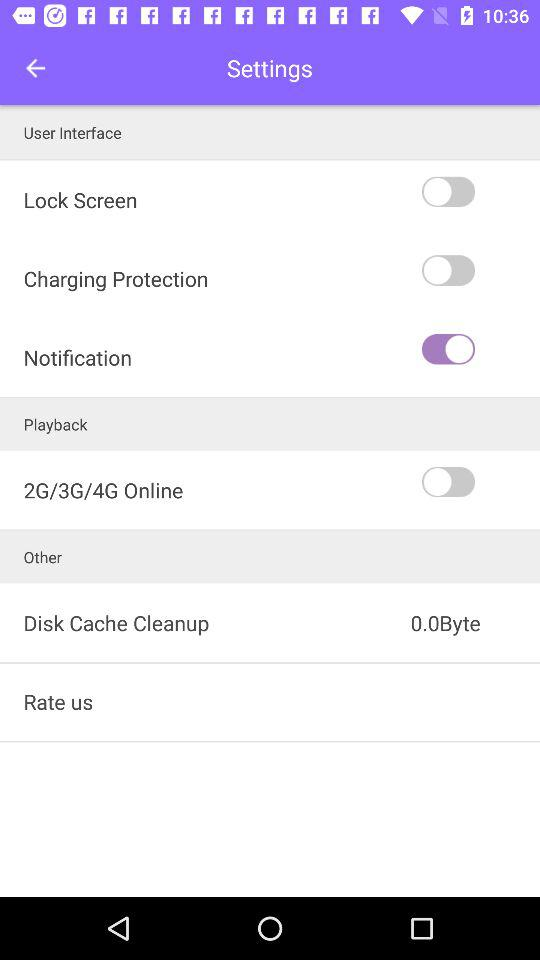What is the status of the lock screen configuration? The status of the lock screen configuration is off. 